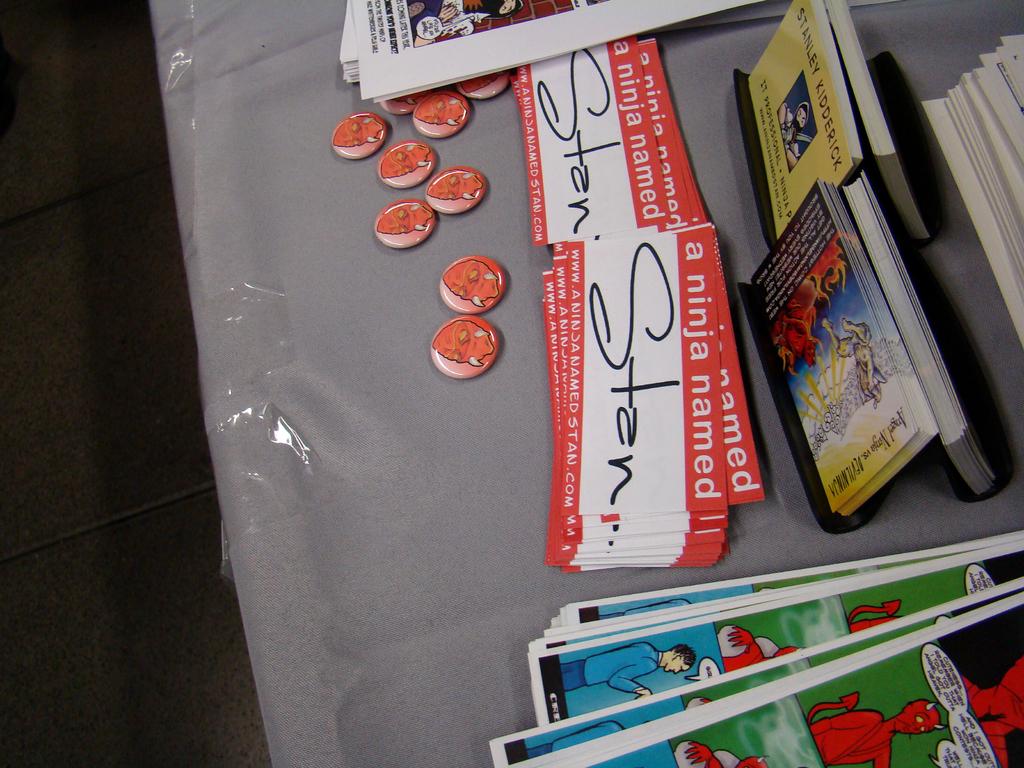What's the name on these nametags?
Your response must be concise. Stan. What name is on the yellow business card?
Your answer should be compact. Stanley kidderick. 